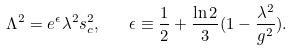Convert formula to latex. <formula><loc_0><loc_0><loc_500><loc_500>\Lambda ^ { 2 } = e ^ { \epsilon } \lambda ^ { 2 } s _ { c } ^ { 2 } , \quad \epsilon \equiv \frac { 1 } { 2 } + \frac { \ln 2 } { 3 } ( 1 - \frac { \lambda ^ { 2 } } { g ^ { 2 } } ) .</formula> 